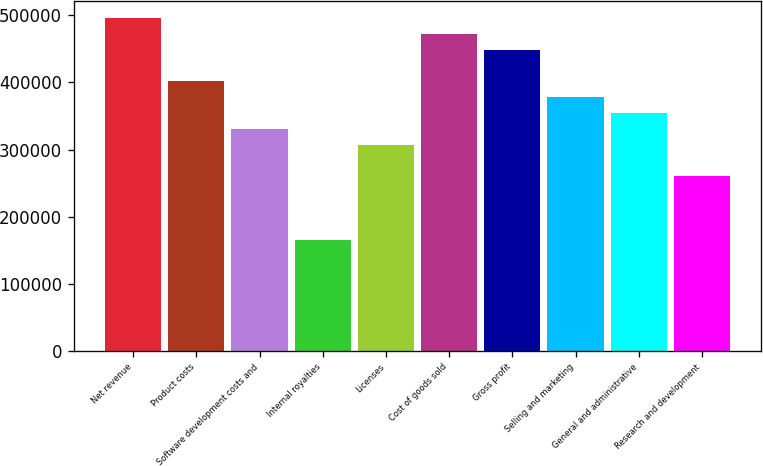<chart> <loc_0><loc_0><loc_500><loc_500><bar_chart><fcel>Net revenue<fcel>Product costs<fcel>Software development costs and<fcel>Internal royalties<fcel>Licenses<fcel>Cost of goods sold<fcel>Gross profit<fcel>Selling and marketing<fcel>General and administrative<fcel>Research and development<nl><fcel>496282<fcel>401752<fcel>330855<fcel>165428<fcel>307222<fcel>472650<fcel>449017<fcel>378120<fcel>354487<fcel>259957<nl></chart> 